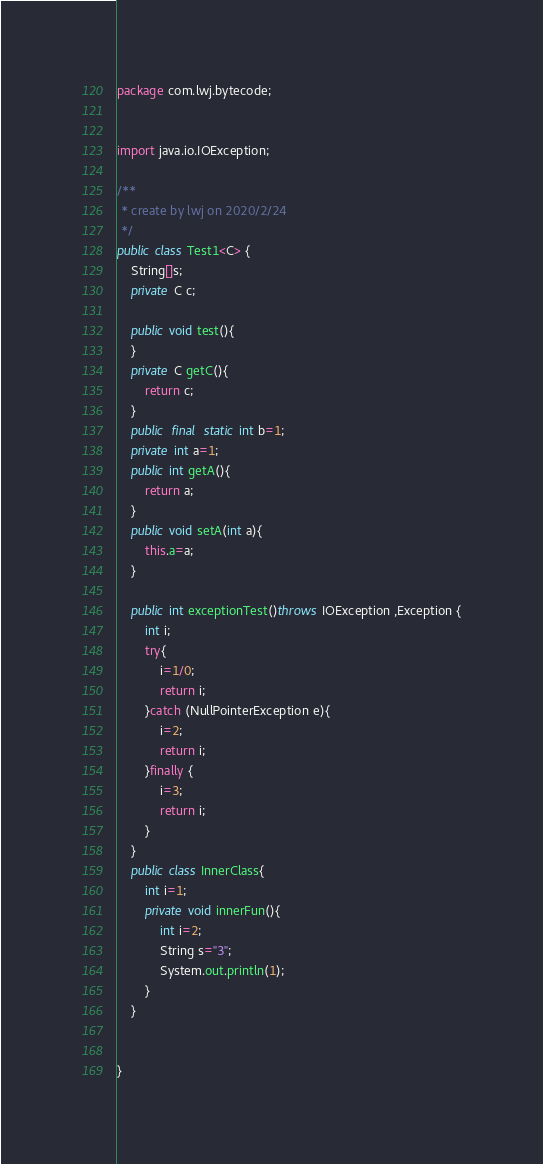Convert code to text. <code><loc_0><loc_0><loc_500><loc_500><_Java_>package com.lwj.bytecode;


import java.io.IOException;

/**
 * create by lwj on 2020/2/24
 */
public class Test1<C> {
    String[]s;
    private C c;

    public void test(){
    }
    private C getC(){
        return c;
    }
    public  final  static int b=1;
    private int a=1;
    public int getA(){
        return a;
    }
    public void setA(int a){
        this.a=a;
    }

    public int exceptionTest()throws IOException ,Exception {
        int i;
        try{
            i=1/0;
            return i;
        }catch (NullPointerException e){
            i=2;
            return i;
        }finally {
            i=3;
            return i;
        }
    }
    public class InnerClass{
        int i=1;
        private void innerFun(){
            int i=2;
            String s="3";
            System.out.println(1);
        }
    }


}
</code> 